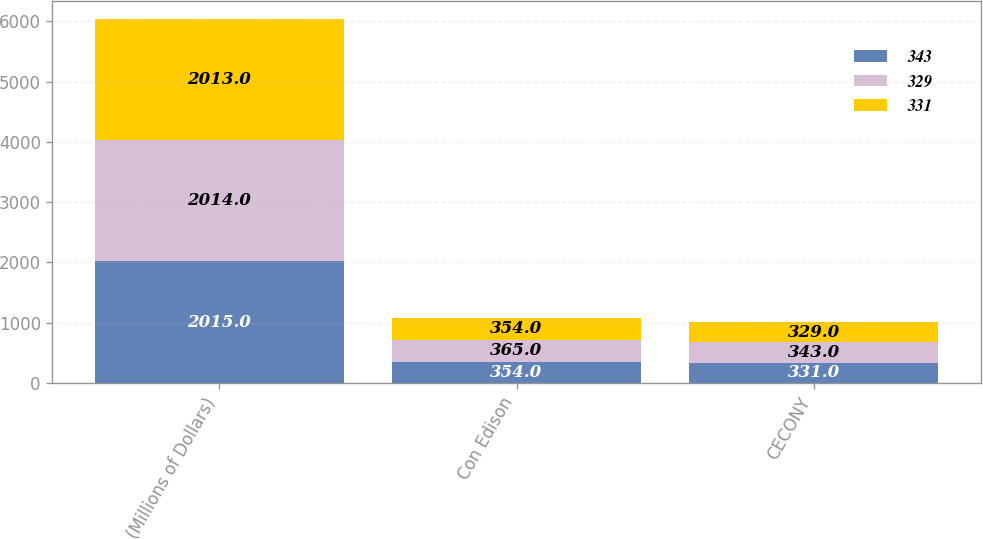Convert chart to OTSL. <chart><loc_0><loc_0><loc_500><loc_500><stacked_bar_chart><ecel><fcel>(Millions of Dollars)<fcel>Con Edison<fcel>CECONY<nl><fcel>343<fcel>2015<fcel>354<fcel>331<nl><fcel>329<fcel>2014<fcel>365<fcel>343<nl><fcel>331<fcel>2013<fcel>354<fcel>329<nl></chart> 